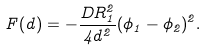Convert formula to latex. <formula><loc_0><loc_0><loc_500><loc_500>F ( d ) = - \frac { D R _ { 1 } ^ { 2 } } { 4 d ^ { 2 } } ( \phi _ { 1 } - \phi _ { 2 } ) ^ { 2 } .</formula> 